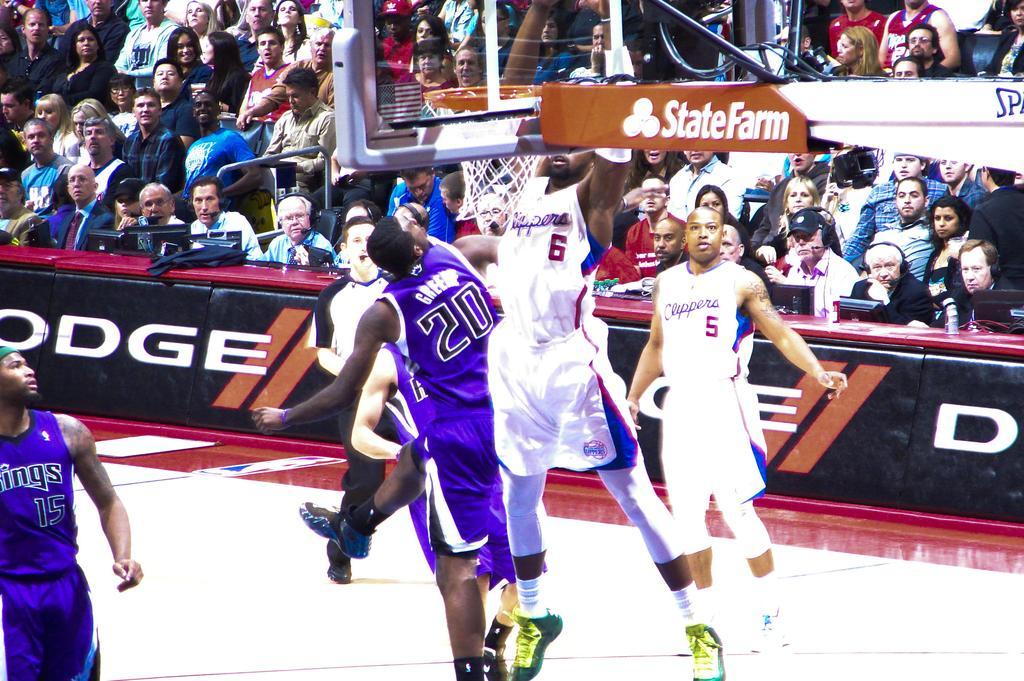Describe this image in one or two sentences. In the picture i can see some persons wearing blue and white color sports dress playing basket ball and in the background of the picture there are some persons sitting on chairs behind table on which there are some computers, microphones and some other things. 